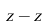Convert formula to latex. <formula><loc_0><loc_0><loc_500><loc_500>z - \hat { z }</formula> 